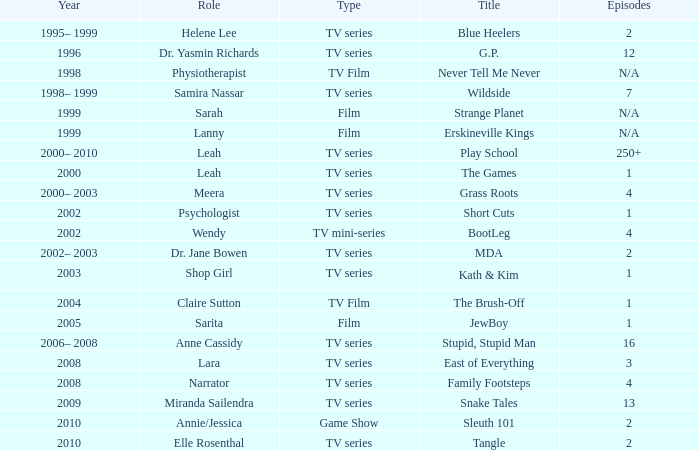What episode is called jewboy 1.0. 